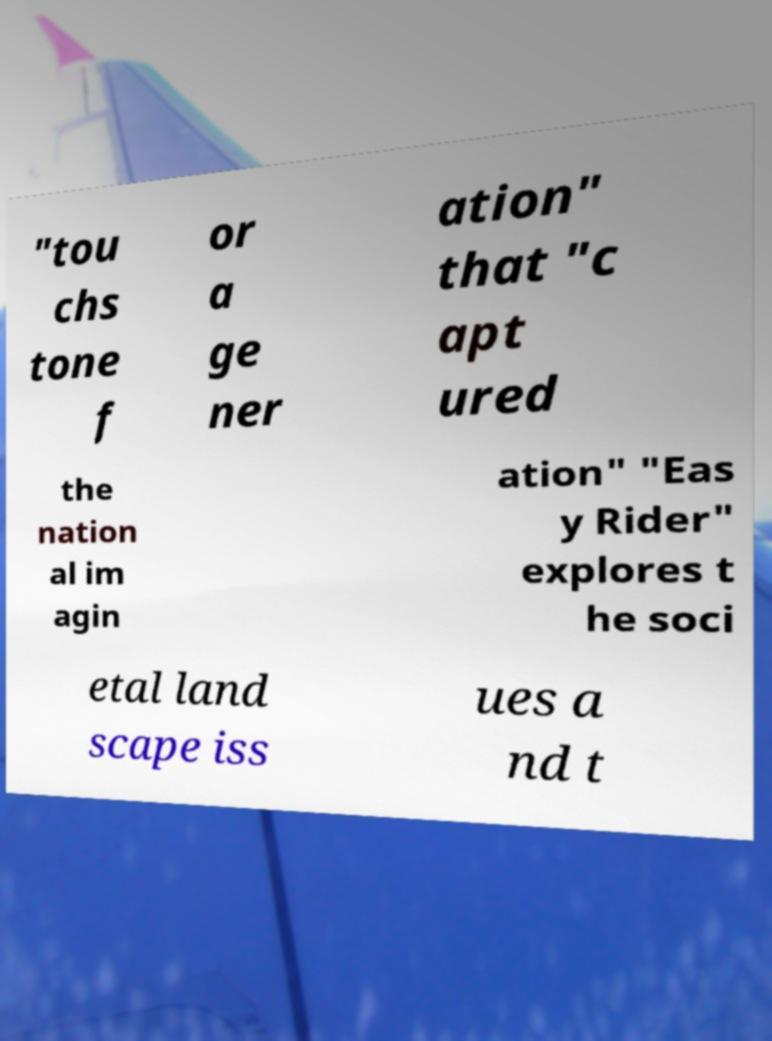Can you read and provide the text displayed in the image?This photo seems to have some interesting text. Can you extract and type it out for me? "tou chs tone f or a ge ner ation" that "c apt ured the nation al im agin ation" "Eas y Rider" explores t he soci etal land scape iss ues a nd t 